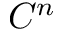Convert formula to latex. <formula><loc_0><loc_0><loc_500><loc_500>C ^ { n }</formula> 